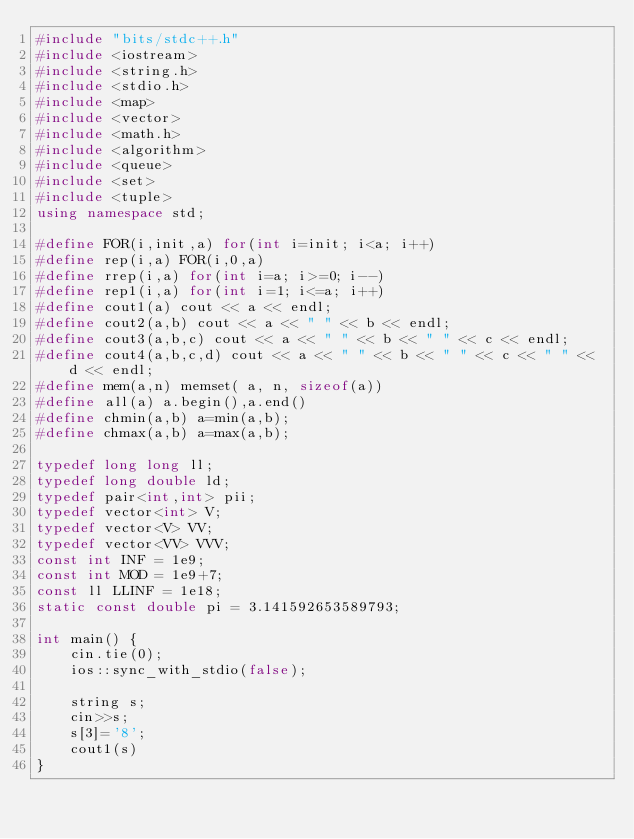<code> <loc_0><loc_0><loc_500><loc_500><_C++_>#include "bits/stdc++.h"
#include <iostream>
#include <string.h>
#include <stdio.h>
#include <map>
#include <vector>
#include <math.h>
#include <algorithm>
#include <queue>
#include <set>
#include <tuple>
using namespace std;

#define FOR(i,init,a) for(int i=init; i<a; i++)
#define rep(i,a) FOR(i,0,a)
#define rrep(i,a) for(int i=a; i>=0; i--)
#define rep1(i,a) for(int i=1; i<=a; i++)
#define cout1(a) cout << a << endl;
#define cout2(a,b) cout << a << " " << b << endl;
#define cout3(a,b,c) cout << a << " " << b << " " << c << endl;
#define cout4(a,b,c,d) cout << a << " " << b << " " << c << " " << d << endl;
#define mem(a,n) memset( a, n, sizeof(a))
#define all(a) a.begin(),a.end()
#define chmin(a,b) a=min(a,b);
#define chmax(a,b) a=max(a,b);

typedef long long ll;
typedef long double ld;
typedef pair<int,int> pii;
typedef vector<int> V;
typedef vector<V> VV;
typedef vector<VV> VVV;
const int INF = 1e9;
const int MOD = 1e9+7;
const ll LLINF = 1e18;
static const double pi = 3.141592653589793;

int main() {
    cin.tie(0);
    ios::sync_with_stdio(false);
    
    string s;
    cin>>s;
    s[3]='8';
    cout1(s)
}</code> 